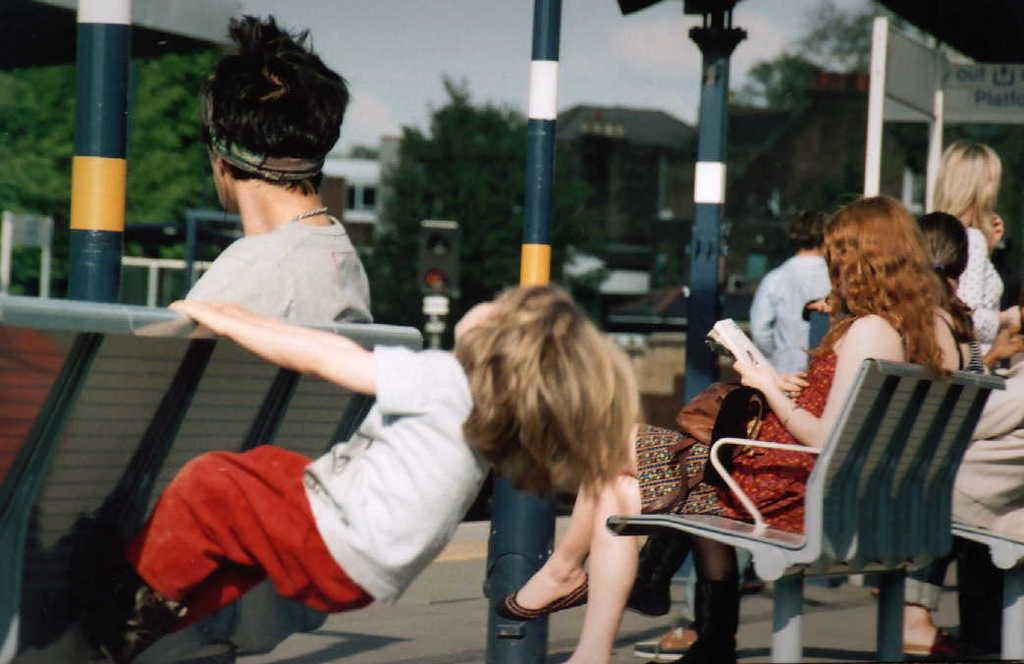What are the people in the image doing? The people in the image are sitting on chairs. What are the people watching? The people are watching something, but it is not specified in the facts. Can you describe the girl in the image? There is a girl in the image, and she is playing with chairs. What is the temper of the porter in the image? There is no porter present in the image, so it is not possible to determine their temper. 